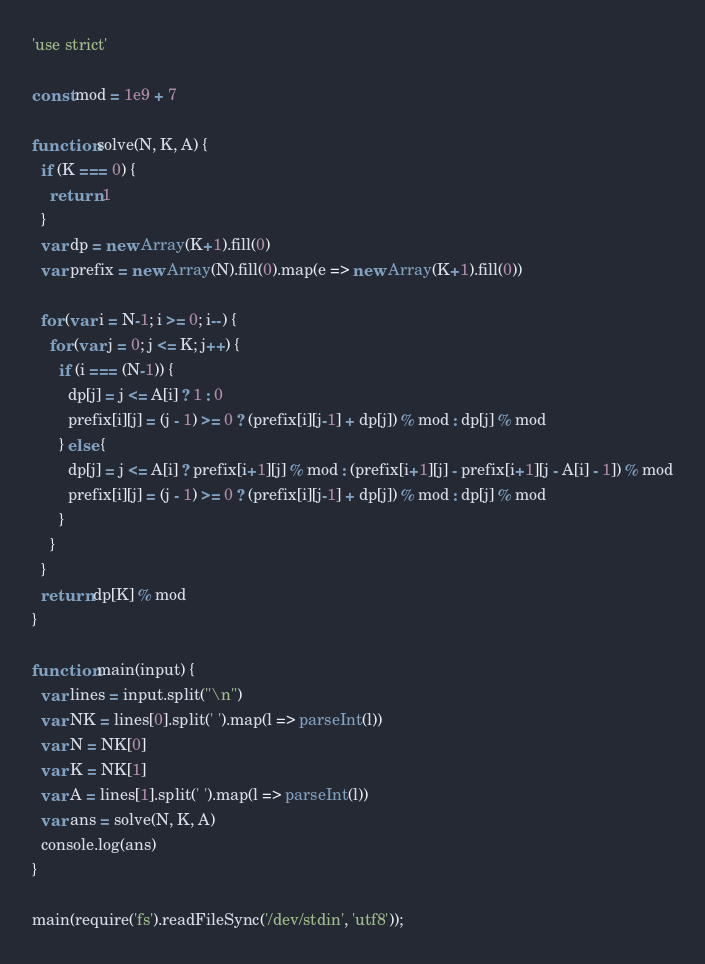Convert code to text. <code><loc_0><loc_0><loc_500><loc_500><_JavaScript_>'use strict'

const mod = 1e9 + 7

function solve(N, K, A) {
  if (K === 0) {
    return 1
  }
  var dp = new Array(K+1).fill(0)
  var prefix = new Array(N).fill(0).map(e => new Array(K+1).fill(0))

  for (var i = N-1; i >= 0; i--) {
    for (var j = 0; j <= K; j++) {
      if (i === (N-1)) {
        dp[j] = j <= A[i] ? 1 : 0
        prefix[i][j] = (j - 1) >= 0 ? (prefix[i][j-1] + dp[j]) % mod : dp[j] % mod
      } else {
        dp[j] = j <= A[i] ? prefix[i+1][j] % mod : (prefix[i+1][j] - prefix[i+1][j - A[i] - 1]) % mod
        prefix[i][j] = (j - 1) >= 0 ? (prefix[i][j-1] + dp[j]) % mod : dp[j] % mod
      }
    }
  }
  return dp[K] % mod
}

function main(input) {
  var lines = input.split("\n")
  var NK = lines[0].split(' ').map(l => parseInt(l))
  var N = NK[0]
  var K = NK[1]
  var A = lines[1].split(' ').map(l => parseInt(l))
  var ans = solve(N, K, A)
  console.log(ans)
}

main(require('fs').readFileSync('/dev/stdin', 'utf8'));</code> 